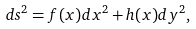Convert formula to latex. <formula><loc_0><loc_0><loc_500><loc_500>d s ^ { 2 } = f ( x ) d x ^ { 2 } + h ( x ) d y ^ { 2 } ,</formula> 